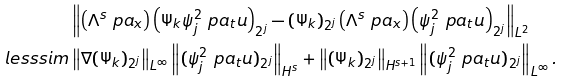Convert formula to latex. <formula><loc_0><loc_0><loc_500><loc_500>& \left \| \left ( \Lambda ^ { s } \ p a _ { x } \right ) \left ( \Psi _ { k } \psi _ { j } ^ { 2 } \ p a _ { t } u \right ) _ { 2 ^ { j } } - ( \Psi _ { k } ) _ { 2 ^ { j } } \left ( \Lambda ^ { s } \ p a _ { x } \right ) \left ( \psi _ { j } ^ { 2 } \ p a _ { t } u \right ) _ { 2 ^ { j } } \right \| _ { L ^ { 2 } } \\ \quad l e s s s i m & \left \| \nabla ( \Psi _ { k } ) _ { 2 ^ { j } } \right \| _ { L ^ { \infty } } \left \| ( \psi _ { j } ^ { 2 } \ p a _ { t } u ) _ { 2 ^ { j } } \right \| _ { H ^ { s } } + \left \| ( \Psi _ { k } ) _ { 2 ^ { j } } \right \| _ { H ^ { s + 1 } } \left \| ( \psi _ { j } ^ { 2 } \ p a _ { t } u ) _ { 2 ^ { j } } \right \| _ { L ^ { \infty } } .</formula> 